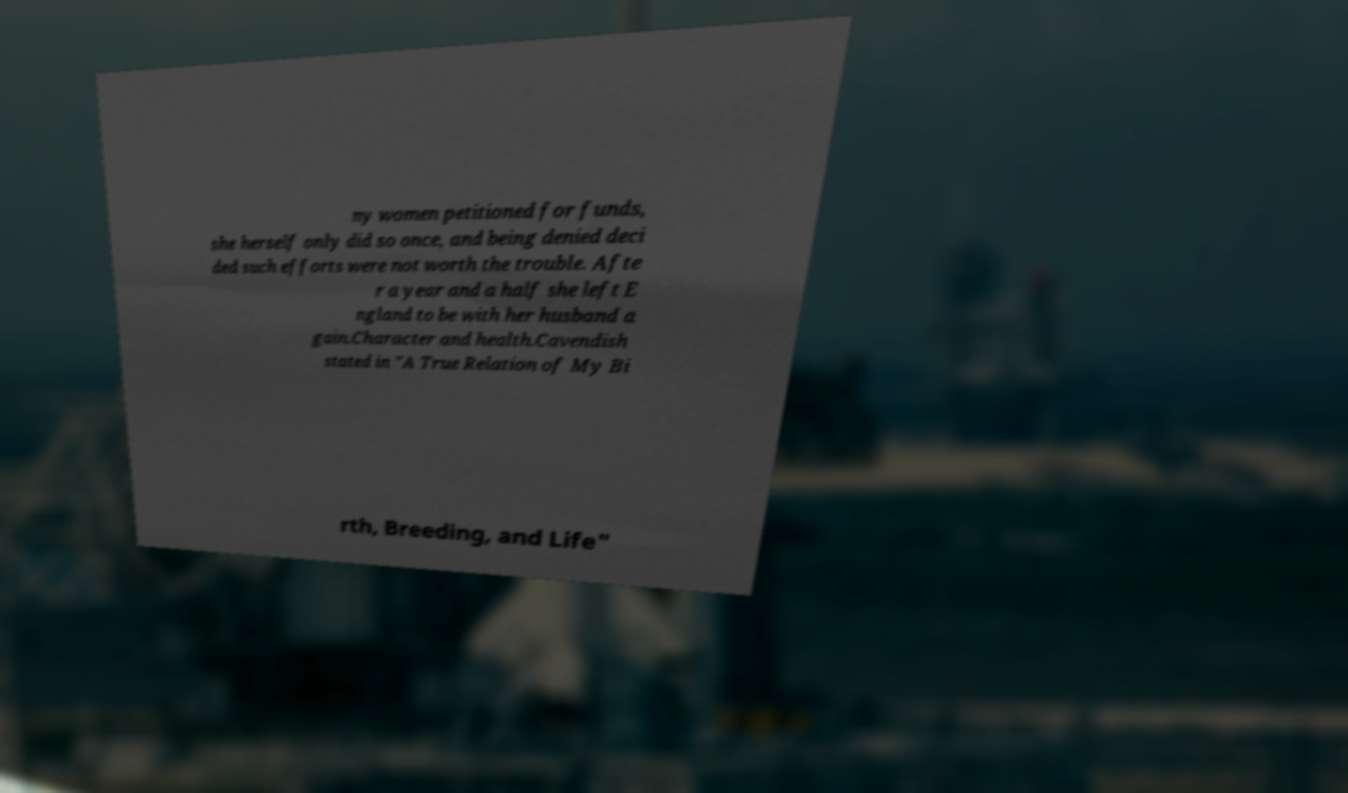Could you assist in decoding the text presented in this image and type it out clearly? ny women petitioned for funds, she herself only did so once, and being denied deci ded such efforts were not worth the trouble. Afte r a year and a half she left E ngland to be with her husband a gain.Character and health.Cavendish stated in "A True Relation of My Bi rth, Breeding, and Life" 